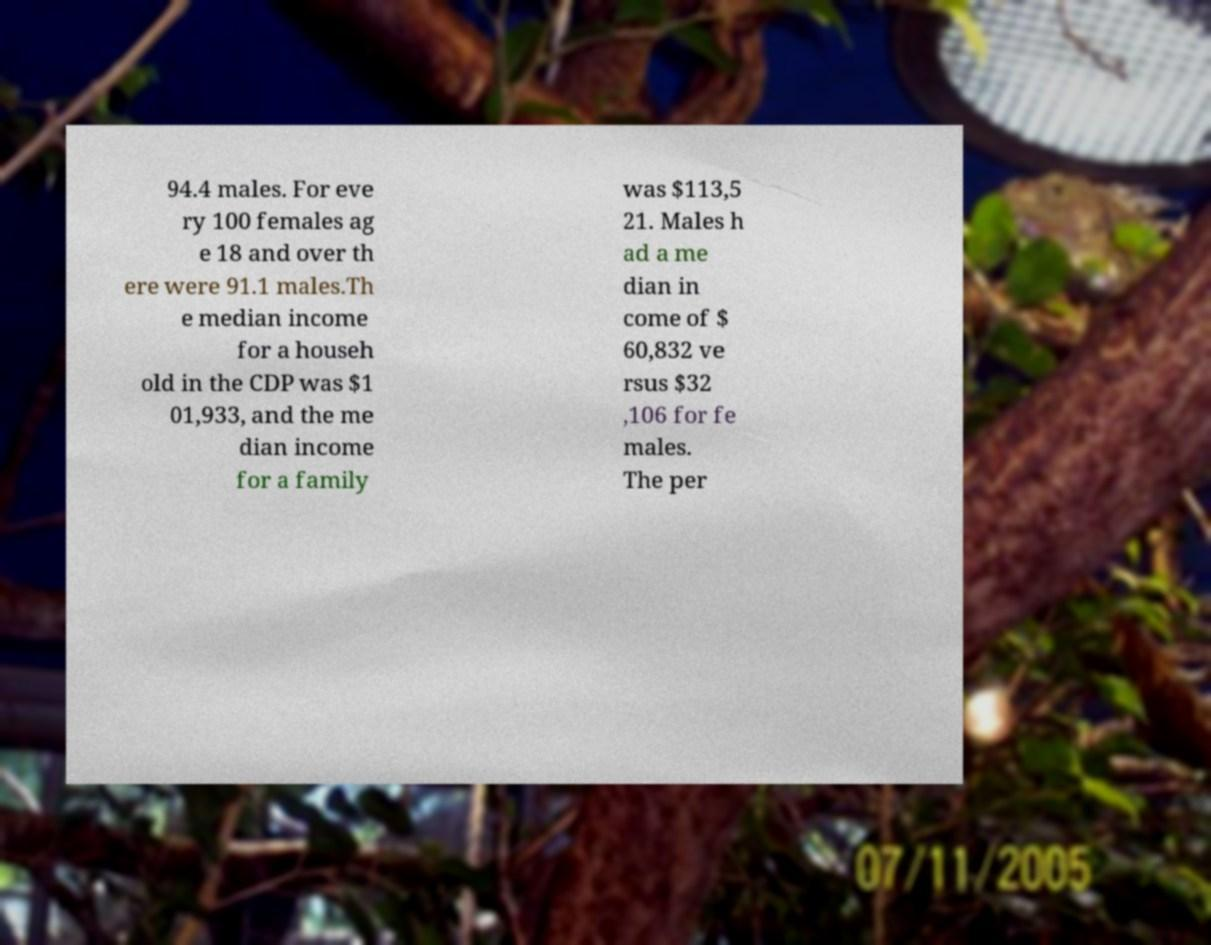There's text embedded in this image that I need extracted. Can you transcribe it verbatim? 94.4 males. For eve ry 100 females ag e 18 and over th ere were 91.1 males.Th e median income for a househ old in the CDP was $1 01,933, and the me dian income for a family was $113,5 21. Males h ad a me dian in come of $ 60,832 ve rsus $32 ,106 for fe males. The per 